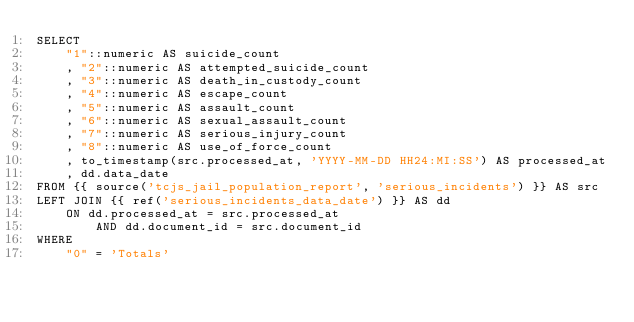<code> <loc_0><loc_0><loc_500><loc_500><_SQL_>SELECT
    "1"::numeric AS suicide_count
    , "2"::numeric AS attempted_suicide_count
    , "3"::numeric AS death_in_custody_count
    , "4"::numeric AS escape_count
    , "5"::numeric AS assault_count
    , "6"::numeric AS sexual_assault_count
    , "7"::numeric AS serious_injury_count
    , "8"::numeric AS use_of_force_count
    , to_timestamp(src.processed_at, 'YYYY-MM-DD HH24:MI:SS') AS processed_at
    , dd.data_date
FROM {{ source('tcjs_jail_population_report', 'serious_incidents') }} AS src
LEFT JOIN {{ ref('serious_incidents_data_date') }} AS dd
    ON dd.processed_at = src.processed_at
        AND dd.document_id = src.document_id
WHERE
    "0" = 'Totals'
</code> 